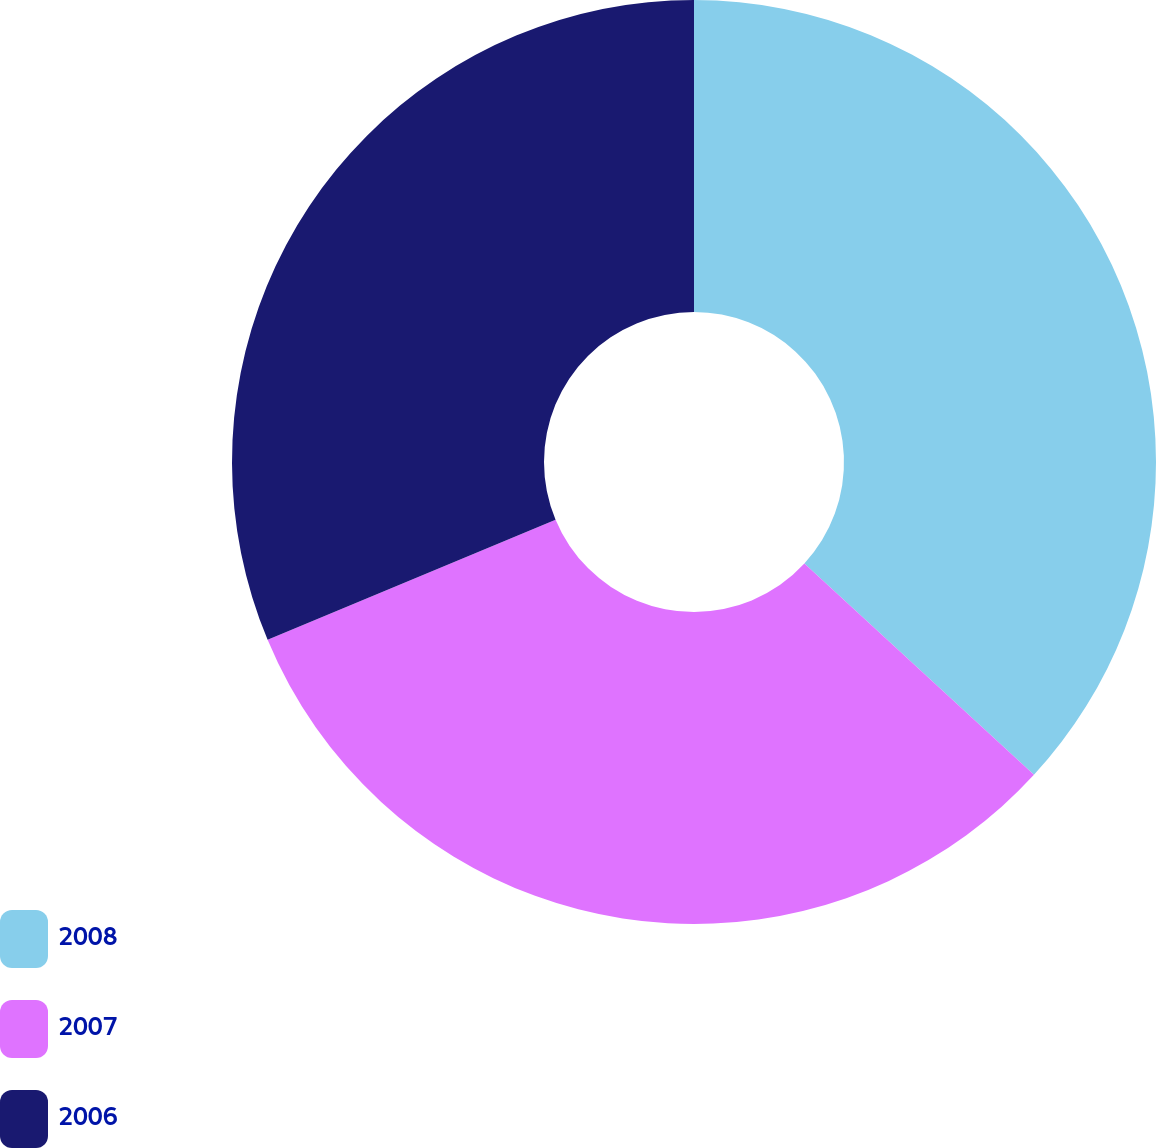Convert chart. <chart><loc_0><loc_0><loc_500><loc_500><pie_chart><fcel>2008<fcel>2007<fcel>2006<nl><fcel>36.84%<fcel>31.87%<fcel>31.29%<nl></chart> 